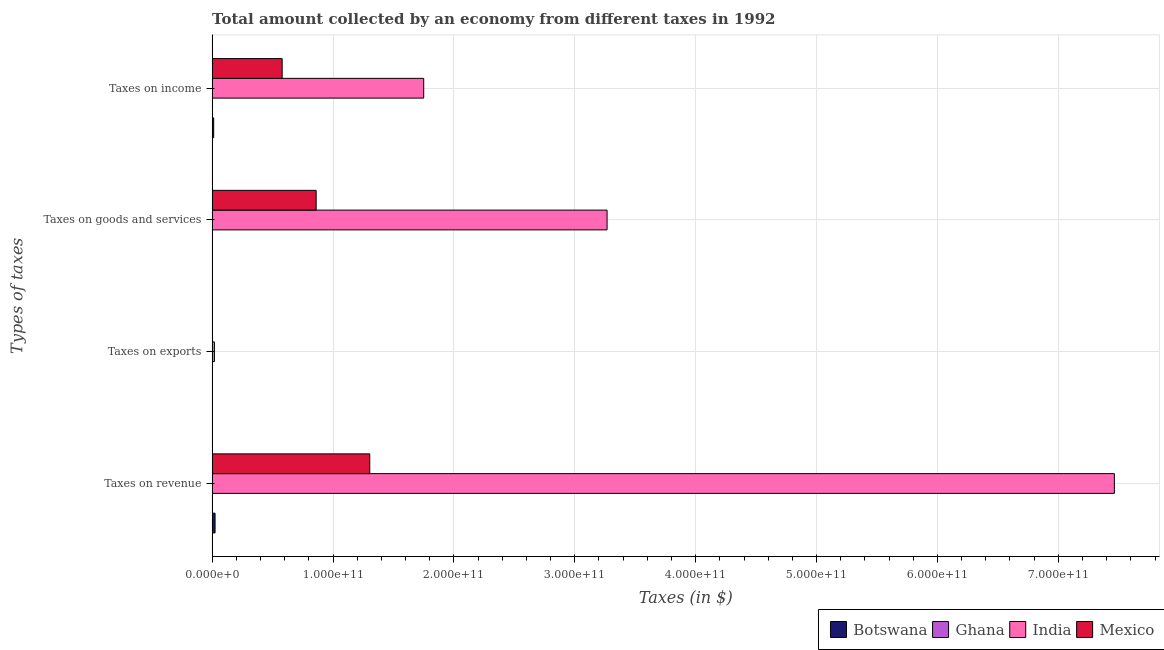How many groups of bars are there?
Your response must be concise. 4. Are the number of bars on each tick of the Y-axis equal?
Your response must be concise. Yes. How many bars are there on the 2nd tick from the bottom?
Keep it short and to the point. 4. What is the label of the 4th group of bars from the top?
Offer a very short reply. Taxes on revenue. What is the amount collected as tax on revenue in India?
Your answer should be compact. 7.46e+11. Across all countries, what is the maximum amount collected as tax on revenue?
Offer a very short reply. 7.46e+11. Across all countries, what is the minimum amount collected as tax on income?
Provide a succinct answer. 6.21e+06. In which country was the amount collected as tax on revenue maximum?
Keep it short and to the point. India. What is the total amount collected as tax on revenue in the graph?
Provide a short and direct response. 8.79e+11. What is the difference between the amount collected as tax on revenue in Ghana and that in India?
Give a very brief answer. -7.46e+11. What is the difference between the amount collected as tax on revenue in Mexico and the amount collected as tax on income in Botswana?
Offer a very short reply. 1.29e+11. What is the average amount collected as tax on income per country?
Keep it short and to the point. 5.86e+1. What is the difference between the amount collected as tax on revenue and amount collected as tax on income in Ghana?
Offer a terse response. 2.40e+07. What is the ratio of the amount collected as tax on goods in Mexico to that in Botswana?
Provide a short and direct response. 641.75. Is the amount collected as tax on income in Mexico less than that in Ghana?
Keep it short and to the point. No. Is the difference between the amount collected as tax on exports in Botswana and Ghana greater than the difference between the amount collected as tax on income in Botswana and Ghana?
Provide a short and direct response. No. What is the difference between the highest and the second highest amount collected as tax on revenue?
Give a very brief answer. 6.16e+11. What is the difference between the highest and the lowest amount collected as tax on exports?
Offer a terse response. 1.91e+09. In how many countries, is the amount collected as tax on revenue greater than the average amount collected as tax on revenue taken over all countries?
Make the answer very short. 1. What does the 2nd bar from the top in Taxes on exports represents?
Provide a short and direct response. India. What does the 1st bar from the bottom in Taxes on exports represents?
Offer a very short reply. Botswana. Is it the case that in every country, the sum of the amount collected as tax on revenue and amount collected as tax on exports is greater than the amount collected as tax on goods?
Your answer should be very brief. Yes. How many bars are there?
Make the answer very short. 16. Are all the bars in the graph horizontal?
Your answer should be very brief. Yes. How many countries are there in the graph?
Offer a terse response. 4. What is the difference between two consecutive major ticks on the X-axis?
Your response must be concise. 1.00e+11. How are the legend labels stacked?
Offer a very short reply. Horizontal. What is the title of the graph?
Offer a terse response. Total amount collected by an economy from different taxes in 1992. What is the label or title of the X-axis?
Your answer should be very brief. Taxes (in $). What is the label or title of the Y-axis?
Your answer should be very brief. Types of taxes. What is the Taxes (in $) of Botswana in Taxes on revenue?
Offer a very short reply. 2.44e+09. What is the Taxes (in $) of Ghana in Taxes on revenue?
Give a very brief answer. 3.02e+07. What is the Taxes (in $) in India in Taxes on revenue?
Ensure brevity in your answer.  7.46e+11. What is the Taxes (in $) in Mexico in Taxes on revenue?
Ensure brevity in your answer.  1.30e+11. What is the Taxes (in $) of Ghana in Taxes on exports?
Offer a terse response. 2.04e+06. What is the Taxes (in $) in India in Taxes on exports?
Your response must be concise. 1.91e+09. What is the Taxes (in $) in Mexico in Taxes on exports?
Provide a short and direct response. 3.80e+07. What is the Taxes (in $) in Botswana in Taxes on goods and services?
Offer a very short reply. 1.34e+08. What is the Taxes (in $) in Ghana in Taxes on goods and services?
Provide a short and direct response. 1.29e+07. What is the Taxes (in $) of India in Taxes on goods and services?
Make the answer very short. 3.27e+11. What is the Taxes (in $) in Mexico in Taxes on goods and services?
Keep it short and to the point. 8.61e+1. What is the Taxes (in $) in Botswana in Taxes on income?
Keep it short and to the point. 1.30e+09. What is the Taxes (in $) of Ghana in Taxes on income?
Your answer should be compact. 6.21e+06. What is the Taxes (in $) in India in Taxes on income?
Your answer should be compact. 1.75e+11. What is the Taxes (in $) in Mexico in Taxes on income?
Provide a short and direct response. 5.79e+1. Across all Types of taxes, what is the maximum Taxes (in $) of Botswana?
Keep it short and to the point. 2.44e+09. Across all Types of taxes, what is the maximum Taxes (in $) in Ghana?
Offer a terse response. 3.02e+07. Across all Types of taxes, what is the maximum Taxes (in $) of India?
Your answer should be compact. 7.46e+11. Across all Types of taxes, what is the maximum Taxes (in $) of Mexico?
Provide a short and direct response. 1.30e+11. Across all Types of taxes, what is the minimum Taxes (in $) of Botswana?
Offer a terse response. 5.00e+05. Across all Types of taxes, what is the minimum Taxes (in $) of Ghana?
Your answer should be compact. 2.04e+06. Across all Types of taxes, what is the minimum Taxes (in $) of India?
Your answer should be compact. 1.91e+09. Across all Types of taxes, what is the minimum Taxes (in $) of Mexico?
Make the answer very short. 3.80e+07. What is the total Taxes (in $) in Botswana in the graph?
Offer a terse response. 3.87e+09. What is the total Taxes (in $) of Ghana in the graph?
Your answer should be compact. 5.13e+07. What is the total Taxes (in $) of India in the graph?
Offer a very short reply. 1.25e+12. What is the total Taxes (in $) in Mexico in the graph?
Provide a succinct answer. 2.74e+11. What is the difference between the Taxes (in $) of Botswana in Taxes on revenue and that in Taxes on exports?
Your answer should be compact. 2.44e+09. What is the difference between the Taxes (in $) in Ghana in Taxes on revenue and that in Taxes on exports?
Provide a succinct answer. 2.81e+07. What is the difference between the Taxes (in $) of India in Taxes on revenue and that in Taxes on exports?
Your response must be concise. 7.44e+11. What is the difference between the Taxes (in $) in Mexico in Taxes on revenue and that in Taxes on exports?
Your answer should be very brief. 1.30e+11. What is the difference between the Taxes (in $) of Botswana in Taxes on revenue and that in Taxes on goods and services?
Provide a succinct answer. 2.30e+09. What is the difference between the Taxes (in $) in Ghana in Taxes on revenue and that in Taxes on goods and services?
Ensure brevity in your answer.  1.73e+07. What is the difference between the Taxes (in $) in India in Taxes on revenue and that in Taxes on goods and services?
Keep it short and to the point. 4.20e+11. What is the difference between the Taxes (in $) of Mexico in Taxes on revenue and that in Taxes on goods and services?
Make the answer very short. 4.43e+1. What is the difference between the Taxes (in $) in Botswana in Taxes on revenue and that in Taxes on income?
Your answer should be very brief. 1.14e+09. What is the difference between the Taxes (in $) in Ghana in Taxes on revenue and that in Taxes on income?
Offer a very short reply. 2.40e+07. What is the difference between the Taxes (in $) of India in Taxes on revenue and that in Taxes on income?
Keep it short and to the point. 5.71e+11. What is the difference between the Taxes (in $) in Mexico in Taxes on revenue and that in Taxes on income?
Make the answer very short. 7.25e+1. What is the difference between the Taxes (in $) of Botswana in Taxes on exports and that in Taxes on goods and services?
Offer a very short reply. -1.34e+08. What is the difference between the Taxes (in $) of Ghana in Taxes on exports and that in Taxes on goods and services?
Provide a succinct answer. -1.08e+07. What is the difference between the Taxes (in $) of India in Taxes on exports and that in Taxes on goods and services?
Offer a very short reply. -3.25e+11. What is the difference between the Taxes (in $) of Mexico in Taxes on exports and that in Taxes on goods and services?
Keep it short and to the point. -8.60e+1. What is the difference between the Taxes (in $) in Botswana in Taxes on exports and that in Taxes on income?
Provide a short and direct response. -1.30e+09. What is the difference between the Taxes (in $) in Ghana in Taxes on exports and that in Taxes on income?
Make the answer very short. -4.17e+06. What is the difference between the Taxes (in $) in India in Taxes on exports and that in Taxes on income?
Provide a succinct answer. -1.73e+11. What is the difference between the Taxes (in $) of Mexico in Taxes on exports and that in Taxes on income?
Provide a succinct answer. -5.79e+1. What is the difference between the Taxes (in $) of Botswana in Taxes on goods and services and that in Taxes on income?
Provide a succinct answer. -1.16e+09. What is the difference between the Taxes (in $) in Ghana in Taxes on goods and services and that in Taxes on income?
Make the answer very short. 6.67e+06. What is the difference between the Taxes (in $) of India in Taxes on goods and services and that in Taxes on income?
Offer a terse response. 1.52e+11. What is the difference between the Taxes (in $) of Mexico in Taxes on goods and services and that in Taxes on income?
Provide a short and direct response. 2.81e+1. What is the difference between the Taxes (in $) of Botswana in Taxes on revenue and the Taxes (in $) of Ghana in Taxes on exports?
Your answer should be compact. 2.43e+09. What is the difference between the Taxes (in $) in Botswana in Taxes on revenue and the Taxes (in $) in India in Taxes on exports?
Provide a succinct answer. 5.26e+08. What is the difference between the Taxes (in $) of Botswana in Taxes on revenue and the Taxes (in $) of Mexico in Taxes on exports?
Make the answer very short. 2.40e+09. What is the difference between the Taxes (in $) of Ghana in Taxes on revenue and the Taxes (in $) of India in Taxes on exports?
Offer a very short reply. -1.88e+09. What is the difference between the Taxes (in $) in Ghana in Taxes on revenue and the Taxes (in $) in Mexico in Taxes on exports?
Ensure brevity in your answer.  -7.82e+06. What is the difference between the Taxes (in $) of India in Taxes on revenue and the Taxes (in $) of Mexico in Taxes on exports?
Offer a terse response. 7.46e+11. What is the difference between the Taxes (in $) in Botswana in Taxes on revenue and the Taxes (in $) in Ghana in Taxes on goods and services?
Provide a succinct answer. 2.42e+09. What is the difference between the Taxes (in $) of Botswana in Taxes on revenue and the Taxes (in $) of India in Taxes on goods and services?
Give a very brief answer. -3.24e+11. What is the difference between the Taxes (in $) in Botswana in Taxes on revenue and the Taxes (in $) in Mexico in Taxes on goods and services?
Provide a short and direct response. -8.36e+1. What is the difference between the Taxes (in $) in Ghana in Taxes on revenue and the Taxes (in $) in India in Taxes on goods and services?
Offer a very short reply. -3.27e+11. What is the difference between the Taxes (in $) in Ghana in Taxes on revenue and the Taxes (in $) in Mexico in Taxes on goods and services?
Ensure brevity in your answer.  -8.60e+1. What is the difference between the Taxes (in $) in India in Taxes on revenue and the Taxes (in $) in Mexico in Taxes on goods and services?
Offer a very short reply. 6.60e+11. What is the difference between the Taxes (in $) of Botswana in Taxes on revenue and the Taxes (in $) of Ghana in Taxes on income?
Offer a very short reply. 2.43e+09. What is the difference between the Taxes (in $) in Botswana in Taxes on revenue and the Taxes (in $) in India in Taxes on income?
Offer a terse response. -1.73e+11. What is the difference between the Taxes (in $) of Botswana in Taxes on revenue and the Taxes (in $) of Mexico in Taxes on income?
Offer a terse response. -5.55e+1. What is the difference between the Taxes (in $) in Ghana in Taxes on revenue and the Taxes (in $) in India in Taxes on income?
Offer a very short reply. -1.75e+11. What is the difference between the Taxes (in $) of Ghana in Taxes on revenue and the Taxes (in $) of Mexico in Taxes on income?
Your answer should be compact. -5.79e+1. What is the difference between the Taxes (in $) in India in Taxes on revenue and the Taxes (in $) in Mexico in Taxes on income?
Your response must be concise. 6.88e+11. What is the difference between the Taxes (in $) of Botswana in Taxes on exports and the Taxes (in $) of Ghana in Taxes on goods and services?
Your answer should be very brief. -1.24e+07. What is the difference between the Taxes (in $) of Botswana in Taxes on exports and the Taxes (in $) of India in Taxes on goods and services?
Your answer should be very brief. -3.27e+11. What is the difference between the Taxes (in $) of Botswana in Taxes on exports and the Taxes (in $) of Mexico in Taxes on goods and services?
Provide a short and direct response. -8.61e+1. What is the difference between the Taxes (in $) in Ghana in Taxes on exports and the Taxes (in $) in India in Taxes on goods and services?
Give a very brief answer. -3.27e+11. What is the difference between the Taxes (in $) of Ghana in Taxes on exports and the Taxes (in $) of Mexico in Taxes on goods and services?
Make the answer very short. -8.61e+1. What is the difference between the Taxes (in $) of India in Taxes on exports and the Taxes (in $) of Mexico in Taxes on goods and services?
Your response must be concise. -8.41e+1. What is the difference between the Taxes (in $) of Botswana in Taxes on exports and the Taxes (in $) of Ghana in Taxes on income?
Ensure brevity in your answer.  -5.71e+06. What is the difference between the Taxes (in $) in Botswana in Taxes on exports and the Taxes (in $) in India in Taxes on income?
Your answer should be compact. -1.75e+11. What is the difference between the Taxes (in $) of Botswana in Taxes on exports and the Taxes (in $) of Mexico in Taxes on income?
Provide a succinct answer. -5.79e+1. What is the difference between the Taxes (in $) of Ghana in Taxes on exports and the Taxes (in $) of India in Taxes on income?
Give a very brief answer. -1.75e+11. What is the difference between the Taxes (in $) in Ghana in Taxes on exports and the Taxes (in $) in Mexico in Taxes on income?
Offer a very short reply. -5.79e+1. What is the difference between the Taxes (in $) in India in Taxes on exports and the Taxes (in $) in Mexico in Taxes on income?
Make the answer very short. -5.60e+1. What is the difference between the Taxes (in $) in Botswana in Taxes on goods and services and the Taxes (in $) in Ghana in Taxes on income?
Ensure brevity in your answer.  1.28e+08. What is the difference between the Taxes (in $) in Botswana in Taxes on goods and services and the Taxes (in $) in India in Taxes on income?
Your answer should be very brief. -1.75e+11. What is the difference between the Taxes (in $) in Botswana in Taxes on goods and services and the Taxes (in $) in Mexico in Taxes on income?
Offer a terse response. -5.78e+1. What is the difference between the Taxes (in $) of Ghana in Taxes on goods and services and the Taxes (in $) of India in Taxes on income?
Offer a terse response. -1.75e+11. What is the difference between the Taxes (in $) of Ghana in Taxes on goods and services and the Taxes (in $) of Mexico in Taxes on income?
Your response must be concise. -5.79e+1. What is the difference between the Taxes (in $) of India in Taxes on goods and services and the Taxes (in $) of Mexico in Taxes on income?
Keep it short and to the point. 2.69e+11. What is the average Taxes (in $) of Botswana per Types of taxes?
Keep it short and to the point. 9.67e+08. What is the average Taxes (in $) of Ghana per Types of taxes?
Your response must be concise. 1.28e+07. What is the average Taxes (in $) in India per Types of taxes?
Your response must be concise. 3.13e+11. What is the average Taxes (in $) of Mexico per Types of taxes?
Provide a short and direct response. 6.86e+1. What is the difference between the Taxes (in $) in Botswana and Taxes (in $) in Ghana in Taxes on revenue?
Your response must be concise. 2.41e+09. What is the difference between the Taxes (in $) of Botswana and Taxes (in $) of India in Taxes on revenue?
Keep it short and to the point. -7.44e+11. What is the difference between the Taxes (in $) of Botswana and Taxes (in $) of Mexico in Taxes on revenue?
Your answer should be compact. -1.28e+11. What is the difference between the Taxes (in $) of Ghana and Taxes (in $) of India in Taxes on revenue?
Your answer should be very brief. -7.46e+11. What is the difference between the Taxes (in $) in Ghana and Taxes (in $) in Mexico in Taxes on revenue?
Your answer should be compact. -1.30e+11. What is the difference between the Taxes (in $) of India and Taxes (in $) of Mexico in Taxes on revenue?
Ensure brevity in your answer.  6.16e+11. What is the difference between the Taxes (in $) of Botswana and Taxes (in $) of Ghana in Taxes on exports?
Offer a terse response. -1.54e+06. What is the difference between the Taxes (in $) of Botswana and Taxes (in $) of India in Taxes on exports?
Your answer should be very brief. -1.91e+09. What is the difference between the Taxes (in $) in Botswana and Taxes (in $) in Mexico in Taxes on exports?
Make the answer very short. -3.75e+07. What is the difference between the Taxes (in $) in Ghana and Taxes (in $) in India in Taxes on exports?
Provide a succinct answer. -1.91e+09. What is the difference between the Taxes (in $) in Ghana and Taxes (in $) in Mexico in Taxes on exports?
Your response must be concise. -3.60e+07. What is the difference between the Taxes (in $) in India and Taxes (in $) in Mexico in Taxes on exports?
Provide a succinct answer. 1.87e+09. What is the difference between the Taxes (in $) in Botswana and Taxes (in $) in Ghana in Taxes on goods and services?
Make the answer very short. 1.21e+08. What is the difference between the Taxes (in $) of Botswana and Taxes (in $) of India in Taxes on goods and services?
Your response must be concise. -3.27e+11. What is the difference between the Taxes (in $) in Botswana and Taxes (in $) in Mexico in Taxes on goods and services?
Keep it short and to the point. -8.59e+1. What is the difference between the Taxes (in $) in Ghana and Taxes (in $) in India in Taxes on goods and services?
Your answer should be compact. -3.27e+11. What is the difference between the Taxes (in $) in Ghana and Taxes (in $) in Mexico in Taxes on goods and services?
Offer a terse response. -8.60e+1. What is the difference between the Taxes (in $) of India and Taxes (in $) of Mexico in Taxes on goods and services?
Provide a succinct answer. 2.41e+11. What is the difference between the Taxes (in $) of Botswana and Taxes (in $) of Ghana in Taxes on income?
Your answer should be compact. 1.29e+09. What is the difference between the Taxes (in $) in Botswana and Taxes (in $) in India in Taxes on income?
Offer a terse response. -1.74e+11. What is the difference between the Taxes (in $) of Botswana and Taxes (in $) of Mexico in Taxes on income?
Offer a terse response. -5.66e+1. What is the difference between the Taxes (in $) in Ghana and Taxes (in $) in India in Taxes on income?
Your answer should be compact. -1.75e+11. What is the difference between the Taxes (in $) of Ghana and Taxes (in $) of Mexico in Taxes on income?
Keep it short and to the point. -5.79e+1. What is the difference between the Taxes (in $) of India and Taxes (in $) of Mexico in Taxes on income?
Offer a terse response. 1.17e+11. What is the ratio of the Taxes (in $) in Botswana in Taxes on revenue to that in Taxes on exports?
Provide a succinct answer. 4871.8. What is the ratio of the Taxes (in $) of Ghana in Taxes on revenue to that in Taxes on exports?
Ensure brevity in your answer.  14.82. What is the ratio of the Taxes (in $) in India in Taxes on revenue to that in Taxes on exports?
Your response must be concise. 390.77. What is the ratio of the Taxes (in $) in Mexico in Taxes on revenue to that in Taxes on exports?
Ensure brevity in your answer.  3431.68. What is the ratio of the Taxes (in $) of Botswana in Taxes on revenue to that in Taxes on goods and services?
Your response must be concise. 18.16. What is the ratio of the Taxes (in $) in Ghana in Taxes on revenue to that in Taxes on goods and services?
Ensure brevity in your answer.  2.34. What is the ratio of the Taxes (in $) in India in Taxes on revenue to that in Taxes on goods and services?
Ensure brevity in your answer.  2.28. What is the ratio of the Taxes (in $) of Mexico in Taxes on revenue to that in Taxes on goods and services?
Your response must be concise. 1.52. What is the ratio of the Taxes (in $) of Botswana in Taxes on revenue to that in Taxes on income?
Make the answer very short. 1.88. What is the ratio of the Taxes (in $) of Ghana in Taxes on revenue to that in Taxes on income?
Offer a terse response. 4.86. What is the ratio of the Taxes (in $) in India in Taxes on revenue to that in Taxes on income?
Your answer should be compact. 4.26. What is the ratio of the Taxes (in $) of Mexico in Taxes on revenue to that in Taxes on income?
Offer a very short reply. 2.25. What is the ratio of the Taxes (in $) in Botswana in Taxes on exports to that in Taxes on goods and services?
Your response must be concise. 0. What is the ratio of the Taxes (in $) in Ghana in Taxes on exports to that in Taxes on goods and services?
Provide a succinct answer. 0.16. What is the ratio of the Taxes (in $) in India in Taxes on exports to that in Taxes on goods and services?
Provide a succinct answer. 0.01. What is the ratio of the Taxes (in $) in Ghana in Taxes on exports to that in Taxes on income?
Provide a short and direct response. 0.33. What is the ratio of the Taxes (in $) of India in Taxes on exports to that in Taxes on income?
Give a very brief answer. 0.01. What is the ratio of the Taxes (in $) in Mexico in Taxes on exports to that in Taxes on income?
Your answer should be compact. 0. What is the ratio of the Taxes (in $) of Botswana in Taxes on goods and services to that in Taxes on income?
Keep it short and to the point. 0.1. What is the ratio of the Taxes (in $) of Ghana in Taxes on goods and services to that in Taxes on income?
Make the answer very short. 2.07. What is the ratio of the Taxes (in $) in India in Taxes on goods and services to that in Taxes on income?
Offer a very short reply. 1.87. What is the ratio of the Taxes (in $) of Mexico in Taxes on goods and services to that in Taxes on income?
Offer a very short reply. 1.49. What is the difference between the highest and the second highest Taxes (in $) of Botswana?
Offer a very short reply. 1.14e+09. What is the difference between the highest and the second highest Taxes (in $) of Ghana?
Offer a terse response. 1.73e+07. What is the difference between the highest and the second highest Taxes (in $) of India?
Make the answer very short. 4.20e+11. What is the difference between the highest and the second highest Taxes (in $) of Mexico?
Keep it short and to the point. 4.43e+1. What is the difference between the highest and the lowest Taxes (in $) in Botswana?
Provide a succinct answer. 2.44e+09. What is the difference between the highest and the lowest Taxes (in $) in Ghana?
Ensure brevity in your answer.  2.81e+07. What is the difference between the highest and the lowest Taxes (in $) of India?
Your answer should be very brief. 7.44e+11. What is the difference between the highest and the lowest Taxes (in $) in Mexico?
Your answer should be compact. 1.30e+11. 